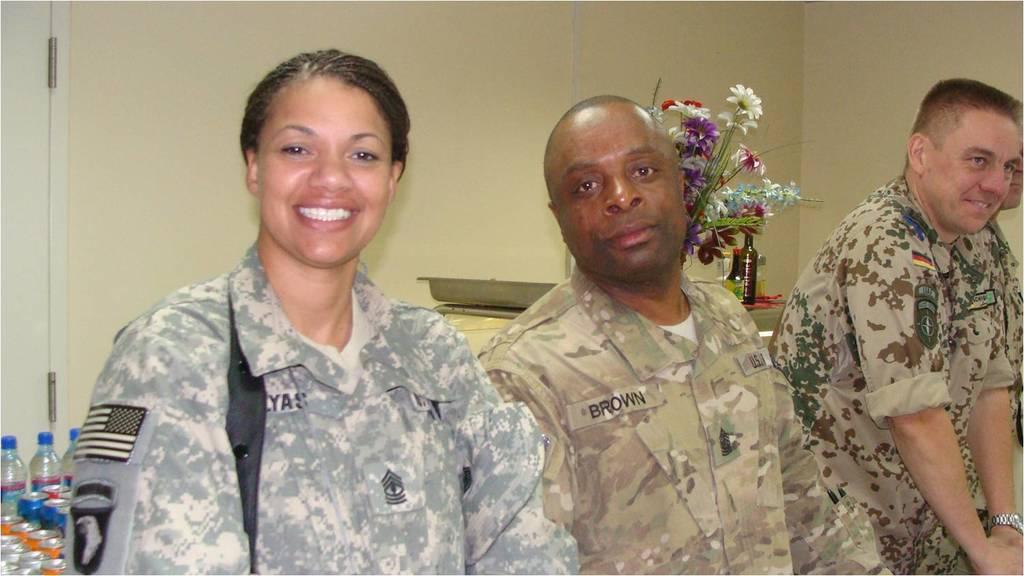How would you summarize this image in a sentence or two? In the picture we can see two men and a woman wearing a army clothes. Back of them, there are bottles and a flower plant. 